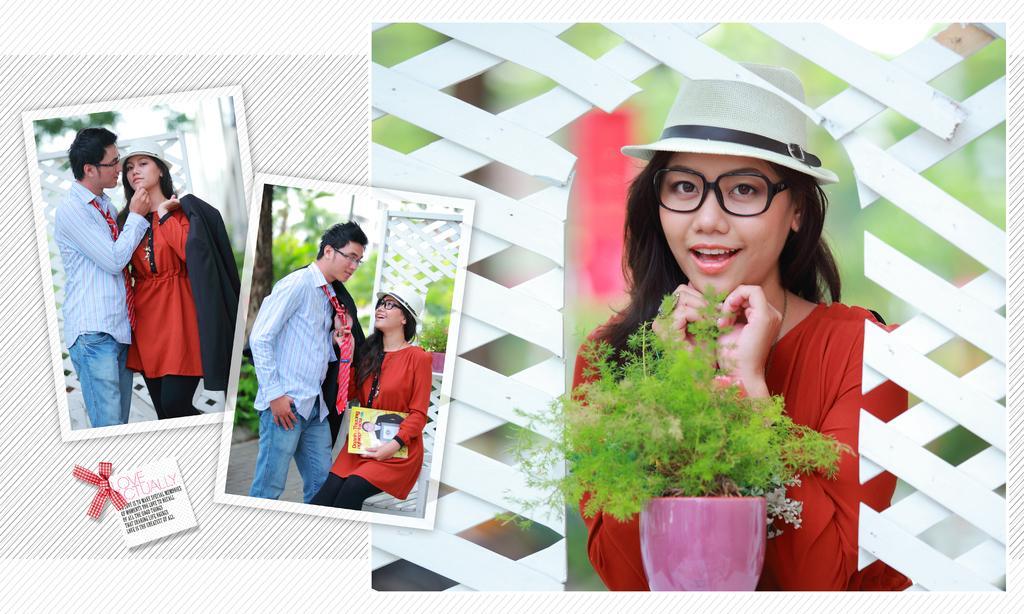In one or two sentences, can you explain what this image depicts? In this image we can see collage photos. There are three photos in the image. There is a plant pot in the image. There are few persons in the image. There is some text at the left bottom of the image. 